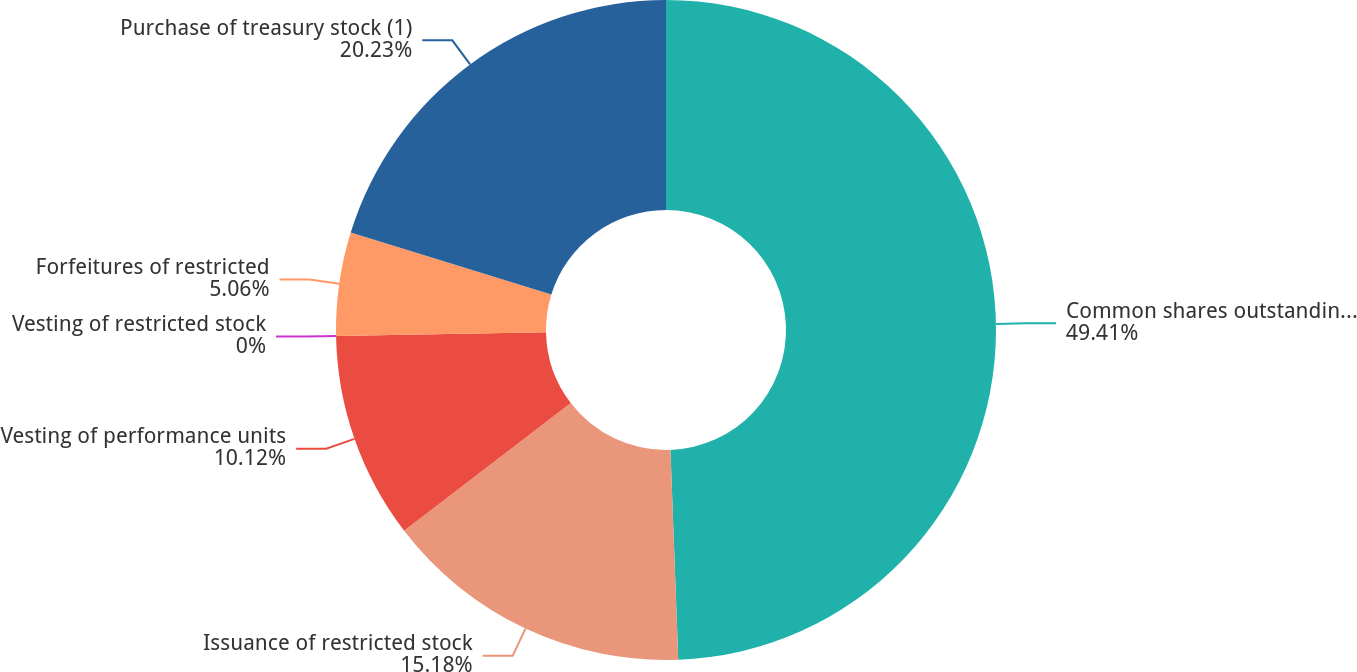Convert chart. <chart><loc_0><loc_0><loc_500><loc_500><pie_chart><fcel>Common shares outstanding at<fcel>Issuance of restricted stock<fcel>Vesting of performance units<fcel>Vesting of restricted stock<fcel>Forfeitures of restricted<fcel>Purchase of treasury stock (1)<nl><fcel>49.41%<fcel>15.18%<fcel>10.12%<fcel>0.0%<fcel>5.06%<fcel>20.23%<nl></chart> 